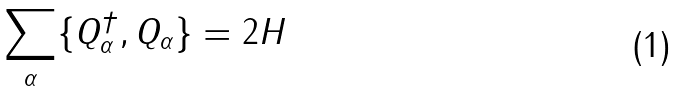<formula> <loc_0><loc_0><loc_500><loc_500>\sum _ { \alpha } \{ Q _ { \alpha } ^ { \dagger } , Q _ { \alpha } \} = 2 H</formula> 